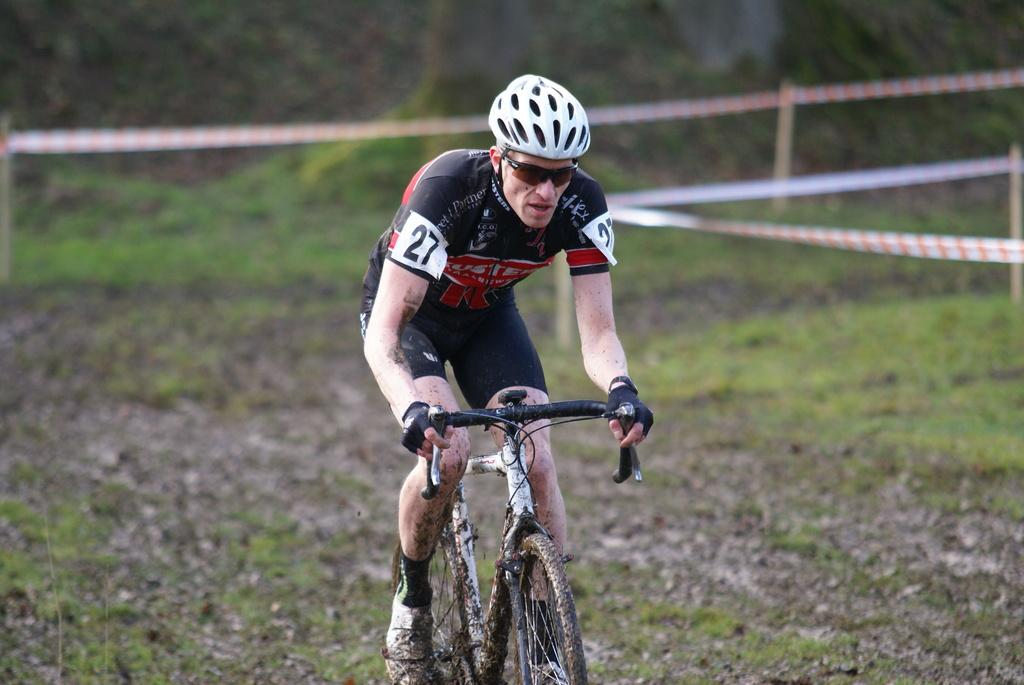What is the main subject of the image? There is a man in the image. What is the man wearing on his head? The man is wearing a helmet. What color is the t-shirt the man is wearing? The man is wearing a black t-shirt. What activity is the man engaged in? The man is riding a bicycle. What is the condition of the bicycle in the image? The bicycle is in the mud. How would you describe the background of the image? The background of the image is blurred. How many trays can be seen in the image? There are no trays present in the image. What is the man measuring in the image? The man is not measuring anything in the image; he is riding a bicycle. 